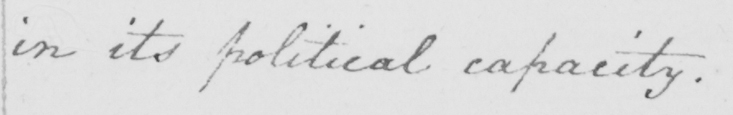What does this handwritten line say? in its political capacity . 